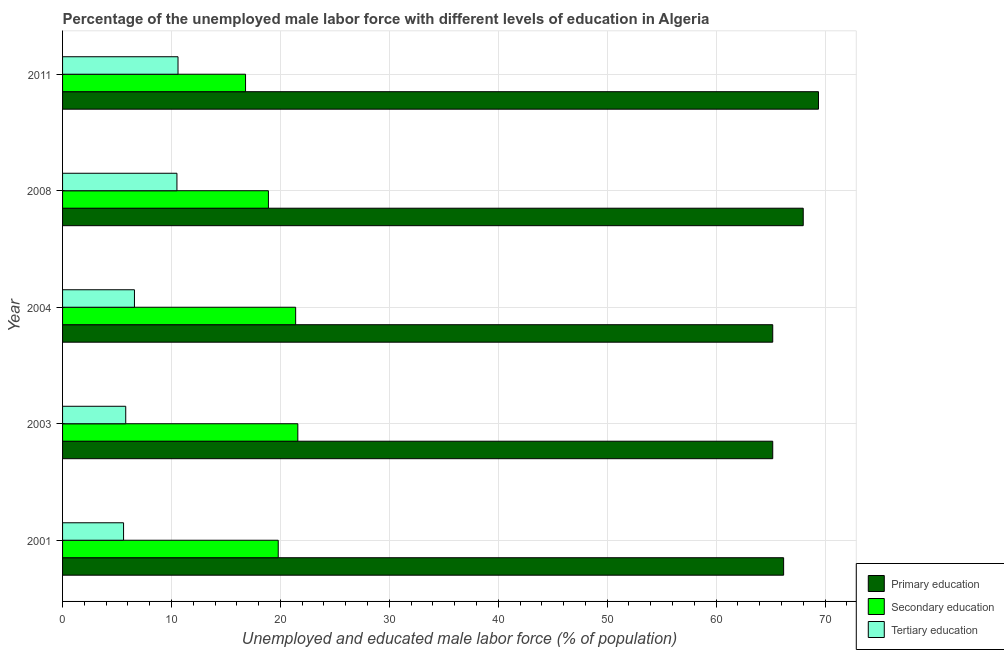How many groups of bars are there?
Offer a terse response. 5. What is the percentage of male labor force who received tertiary education in 2008?
Your answer should be very brief. 10.5. Across all years, what is the maximum percentage of male labor force who received primary education?
Keep it short and to the point. 69.4. Across all years, what is the minimum percentage of male labor force who received secondary education?
Ensure brevity in your answer.  16.8. What is the total percentage of male labor force who received tertiary education in the graph?
Provide a short and direct response. 39.1. What is the difference between the percentage of male labor force who received secondary education in 2001 and that in 2011?
Your answer should be compact. 3. What is the difference between the percentage of male labor force who received primary education in 2001 and the percentage of male labor force who received tertiary education in 2008?
Make the answer very short. 55.7. What is the average percentage of male labor force who received tertiary education per year?
Keep it short and to the point. 7.82. In the year 2008, what is the difference between the percentage of male labor force who received primary education and percentage of male labor force who received secondary education?
Provide a succinct answer. 49.1. What is the ratio of the percentage of male labor force who received secondary education in 2004 to that in 2008?
Your answer should be compact. 1.13. Is the percentage of male labor force who received secondary education in 2004 less than that in 2008?
Make the answer very short. No. Is the difference between the percentage of male labor force who received secondary education in 2003 and 2004 greater than the difference between the percentage of male labor force who received primary education in 2003 and 2004?
Your answer should be compact. Yes. What is the difference between the highest and the second highest percentage of male labor force who received primary education?
Keep it short and to the point. 1.4. What is the difference between the highest and the lowest percentage of male labor force who received primary education?
Provide a short and direct response. 4.2. Is the sum of the percentage of male labor force who received secondary education in 2008 and 2011 greater than the maximum percentage of male labor force who received tertiary education across all years?
Offer a very short reply. Yes. What does the 3rd bar from the top in 2008 represents?
Your answer should be compact. Primary education. What does the 2nd bar from the bottom in 2008 represents?
Provide a succinct answer. Secondary education. How many bars are there?
Your answer should be compact. 15. Are all the bars in the graph horizontal?
Your answer should be compact. Yes. What is the difference between two consecutive major ticks on the X-axis?
Offer a terse response. 10. Are the values on the major ticks of X-axis written in scientific E-notation?
Your answer should be compact. No. Does the graph contain any zero values?
Offer a terse response. No. Where does the legend appear in the graph?
Your response must be concise. Bottom right. What is the title of the graph?
Offer a very short reply. Percentage of the unemployed male labor force with different levels of education in Algeria. What is the label or title of the X-axis?
Give a very brief answer. Unemployed and educated male labor force (% of population). What is the Unemployed and educated male labor force (% of population) in Primary education in 2001?
Your response must be concise. 66.2. What is the Unemployed and educated male labor force (% of population) in Secondary education in 2001?
Keep it short and to the point. 19.8. What is the Unemployed and educated male labor force (% of population) of Tertiary education in 2001?
Ensure brevity in your answer.  5.6. What is the Unemployed and educated male labor force (% of population) in Primary education in 2003?
Make the answer very short. 65.2. What is the Unemployed and educated male labor force (% of population) in Secondary education in 2003?
Your answer should be very brief. 21.6. What is the Unemployed and educated male labor force (% of population) in Tertiary education in 2003?
Ensure brevity in your answer.  5.8. What is the Unemployed and educated male labor force (% of population) of Primary education in 2004?
Make the answer very short. 65.2. What is the Unemployed and educated male labor force (% of population) in Secondary education in 2004?
Offer a terse response. 21.4. What is the Unemployed and educated male labor force (% of population) in Tertiary education in 2004?
Give a very brief answer. 6.6. What is the Unemployed and educated male labor force (% of population) of Primary education in 2008?
Your response must be concise. 68. What is the Unemployed and educated male labor force (% of population) of Secondary education in 2008?
Your answer should be very brief. 18.9. What is the Unemployed and educated male labor force (% of population) of Primary education in 2011?
Give a very brief answer. 69.4. What is the Unemployed and educated male labor force (% of population) of Secondary education in 2011?
Make the answer very short. 16.8. What is the Unemployed and educated male labor force (% of population) in Tertiary education in 2011?
Your answer should be very brief. 10.6. Across all years, what is the maximum Unemployed and educated male labor force (% of population) in Primary education?
Your answer should be very brief. 69.4. Across all years, what is the maximum Unemployed and educated male labor force (% of population) in Secondary education?
Keep it short and to the point. 21.6. Across all years, what is the maximum Unemployed and educated male labor force (% of population) of Tertiary education?
Offer a very short reply. 10.6. Across all years, what is the minimum Unemployed and educated male labor force (% of population) in Primary education?
Give a very brief answer. 65.2. Across all years, what is the minimum Unemployed and educated male labor force (% of population) of Secondary education?
Offer a terse response. 16.8. Across all years, what is the minimum Unemployed and educated male labor force (% of population) in Tertiary education?
Ensure brevity in your answer.  5.6. What is the total Unemployed and educated male labor force (% of population) in Primary education in the graph?
Provide a succinct answer. 334. What is the total Unemployed and educated male labor force (% of population) in Secondary education in the graph?
Offer a very short reply. 98.5. What is the total Unemployed and educated male labor force (% of population) of Tertiary education in the graph?
Ensure brevity in your answer.  39.1. What is the difference between the Unemployed and educated male labor force (% of population) in Primary education in 2001 and that in 2003?
Provide a succinct answer. 1. What is the difference between the Unemployed and educated male labor force (% of population) of Secondary education in 2001 and that in 2003?
Your response must be concise. -1.8. What is the difference between the Unemployed and educated male labor force (% of population) of Primary education in 2001 and that in 2004?
Your answer should be compact. 1. What is the difference between the Unemployed and educated male labor force (% of population) in Secondary education in 2001 and that in 2004?
Provide a short and direct response. -1.6. What is the difference between the Unemployed and educated male labor force (% of population) of Tertiary education in 2001 and that in 2004?
Your answer should be very brief. -1. What is the difference between the Unemployed and educated male labor force (% of population) of Primary education in 2001 and that in 2008?
Keep it short and to the point. -1.8. What is the difference between the Unemployed and educated male labor force (% of population) of Tertiary education in 2001 and that in 2008?
Offer a terse response. -4.9. What is the difference between the Unemployed and educated male labor force (% of population) in Tertiary education in 2001 and that in 2011?
Provide a short and direct response. -5. What is the difference between the Unemployed and educated male labor force (% of population) in Primary education in 2003 and that in 2004?
Your answer should be compact. 0. What is the difference between the Unemployed and educated male labor force (% of population) of Tertiary education in 2003 and that in 2004?
Provide a short and direct response. -0.8. What is the difference between the Unemployed and educated male labor force (% of population) in Primary education in 2003 and that in 2011?
Your answer should be compact. -4.2. What is the difference between the Unemployed and educated male labor force (% of population) in Secondary education in 2003 and that in 2011?
Ensure brevity in your answer.  4.8. What is the difference between the Unemployed and educated male labor force (% of population) in Tertiary education in 2003 and that in 2011?
Provide a succinct answer. -4.8. What is the difference between the Unemployed and educated male labor force (% of population) of Tertiary education in 2004 and that in 2008?
Make the answer very short. -3.9. What is the difference between the Unemployed and educated male labor force (% of population) in Tertiary education in 2004 and that in 2011?
Keep it short and to the point. -4. What is the difference between the Unemployed and educated male labor force (% of population) of Primary education in 2001 and the Unemployed and educated male labor force (% of population) of Secondary education in 2003?
Ensure brevity in your answer.  44.6. What is the difference between the Unemployed and educated male labor force (% of population) in Primary education in 2001 and the Unemployed and educated male labor force (% of population) in Tertiary education in 2003?
Keep it short and to the point. 60.4. What is the difference between the Unemployed and educated male labor force (% of population) of Secondary education in 2001 and the Unemployed and educated male labor force (% of population) of Tertiary education in 2003?
Give a very brief answer. 14. What is the difference between the Unemployed and educated male labor force (% of population) in Primary education in 2001 and the Unemployed and educated male labor force (% of population) in Secondary education in 2004?
Give a very brief answer. 44.8. What is the difference between the Unemployed and educated male labor force (% of population) of Primary education in 2001 and the Unemployed and educated male labor force (% of population) of Tertiary education in 2004?
Your answer should be very brief. 59.6. What is the difference between the Unemployed and educated male labor force (% of population) in Primary education in 2001 and the Unemployed and educated male labor force (% of population) in Secondary education in 2008?
Your response must be concise. 47.3. What is the difference between the Unemployed and educated male labor force (% of population) of Primary education in 2001 and the Unemployed and educated male labor force (% of population) of Tertiary education in 2008?
Give a very brief answer. 55.7. What is the difference between the Unemployed and educated male labor force (% of population) in Primary education in 2001 and the Unemployed and educated male labor force (% of population) in Secondary education in 2011?
Provide a short and direct response. 49.4. What is the difference between the Unemployed and educated male labor force (% of population) in Primary education in 2001 and the Unemployed and educated male labor force (% of population) in Tertiary education in 2011?
Provide a short and direct response. 55.6. What is the difference between the Unemployed and educated male labor force (% of population) of Primary education in 2003 and the Unemployed and educated male labor force (% of population) of Secondary education in 2004?
Provide a succinct answer. 43.8. What is the difference between the Unemployed and educated male labor force (% of population) of Primary education in 2003 and the Unemployed and educated male labor force (% of population) of Tertiary education in 2004?
Provide a short and direct response. 58.6. What is the difference between the Unemployed and educated male labor force (% of population) of Primary education in 2003 and the Unemployed and educated male labor force (% of population) of Secondary education in 2008?
Your answer should be compact. 46.3. What is the difference between the Unemployed and educated male labor force (% of population) in Primary education in 2003 and the Unemployed and educated male labor force (% of population) in Tertiary education in 2008?
Provide a short and direct response. 54.7. What is the difference between the Unemployed and educated male labor force (% of population) in Primary education in 2003 and the Unemployed and educated male labor force (% of population) in Secondary education in 2011?
Ensure brevity in your answer.  48.4. What is the difference between the Unemployed and educated male labor force (% of population) of Primary education in 2003 and the Unemployed and educated male labor force (% of population) of Tertiary education in 2011?
Offer a terse response. 54.6. What is the difference between the Unemployed and educated male labor force (% of population) of Secondary education in 2003 and the Unemployed and educated male labor force (% of population) of Tertiary education in 2011?
Keep it short and to the point. 11. What is the difference between the Unemployed and educated male labor force (% of population) in Primary education in 2004 and the Unemployed and educated male labor force (% of population) in Secondary education in 2008?
Your response must be concise. 46.3. What is the difference between the Unemployed and educated male labor force (% of population) in Primary education in 2004 and the Unemployed and educated male labor force (% of population) in Tertiary education in 2008?
Provide a short and direct response. 54.7. What is the difference between the Unemployed and educated male labor force (% of population) in Primary education in 2004 and the Unemployed and educated male labor force (% of population) in Secondary education in 2011?
Provide a short and direct response. 48.4. What is the difference between the Unemployed and educated male labor force (% of population) of Primary education in 2004 and the Unemployed and educated male labor force (% of population) of Tertiary education in 2011?
Your answer should be very brief. 54.6. What is the difference between the Unemployed and educated male labor force (% of population) in Primary education in 2008 and the Unemployed and educated male labor force (% of population) in Secondary education in 2011?
Give a very brief answer. 51.2. What is the difference between the Unemployed and educated male labor force (% of population) of Primary education in 2008 and the Unemployed and educated male labor force (% of population) of Tertiary education in 2011?
Give a very brief answer. 57.4. What is the average Unemployed and educated male labor force (% of population) of Primary education per year?
Your answer should be compact. 66.8. What is the average Unemployed and educated male labor force (% of population) of Secondary education per year?
Keep it short and to the point. 19.7. What is the average Unemployed and educated male labor force (% of population) of Tertiary education per year?
Make the answer very short. 7.82. In the year 2001, what is the difference between the Unemployed and educated male labor force (% of population) in Primary education and Unemployed and educated male labor force (% of population) in Secondary education?
Keep it short and to the point. 46.4. In the year 2001, what is the difference between the Unemployed and educated male labor force (% of population) of Primary education and Unemployed and educated male labor force (% of population) of Tertiary education?
Offer a very short reply. 60.6. In the year 2001, what is the difference between the Unemployed and educated male labor force (% of population) of Secondary education and Unemployed and educated male labor force (% of population) of Tertiary education?
Ensure brevity in your answer.  14.2. In the year 2003, what is the difference between the Unemployed and educated male labor force (% of population) of Primary education and Unemployed and educated male labor force (% of population) of Secondary education?
Make the answer very short. 43.6. In the year 2003, what is the difference between the Unemployed and educated male labor force (% of population) of Primary education and Unemployed and educated male labor force (% of population) of Tertiary education?
Your answer should be compact. 59.4. In the year 2004, what is the difference between the Unemployed and educated male labor force (% of population) of Primary education and Unemployed and educated male labor force (% of population) of Secondary education?
Offer a terse response. 43.8. In the year 2004, what is the difference between the Unemployed and educated male labor force (% of population) in Primary education and Unemployed and educated male labor force (% of population) in Tertiary education?
Your response must be concise. 58.6. In the year 2004, what is the difference between the Unemployed and educated male labor force (% of population) of Secondary education and Unemployed and educated male labor force (% of population) of Tertiary education?
Offer a very short reply. 14.8. In the year 2008, what is the difference between the Unemployed and educated male labor force (% of population) of Primary education and Unemployed and educated male labor force (% of population) of Secondary education?
Keep it short and to the point. 49.1. In the year 2008, what is the difference between the Unemployed and educated male labor force (% of population) of Primary education and Unemployed and educated male labor force (% of population) of Tertiary education?
Your response must be concise. 57.5. In the year 2011, what is the difference between the Unemployed and educated male labor force (% of population) in Primary education and Unemployed and educated male labor force (% of population) in Secondary education?
Offer a very short reply. 52.6. In the year 2011, what is the difference between the Unemployed and educated male labor force (% of population) of Primary education and Unemployed and educated male labor force (% of population) of Tertiary education?
Ensure brevity in your answer.  58.8. In the year 2011, what is the difference between the Unemployed and educated male labor force (% of population) in Secondary education and Unemployed and educated male labor force (% of population) in Tertiary education?
Offer a terse response. 6.2. What is the ratio of the Unemployed and educated male labor force (% of population) of Primary education in 2001 to that in 2003?
Your answer should be compact. 1.02. What is the ratio of the Unemployed and educated male labor force (% of population) of Tertiary education in 2001 to that in 2003?
Your answer should be compact. 0.97. What is the ratio of the Unemployed and educated male labor force (% of population) in Primary education in 2001 to that in 2004?
Your answer should be compact. 1.02. What is the ratio of the Unemployed and educated male labor force (% of population) of Secondary education in 2001 to that in 2004?
Make the answer very short. 0.93. What is the ratio of the Unemployed and educated male labor force (% of population) in Tertiary education in 2001 to that in 2004?
Your answer should be very brief. 0.85. What is the ratio of the Unemployed and educated male labor force (% of population) of Primary education in 2001 to that in 2008?
Your answer should be very brief. 0.97. What is the ratio of the Unemployed and educated male labor force (% of population) in Secondary education in 2001 to that in 2008?
Your answer should be very brief. 1.05. What is the ratio of the Unemployed and educated male labor force (% of population) of Tertiary education in 2001 to that in 2008?
Your answer should be compact. 0.53. What is the ratio of the Unemployed and educated male labor force (% of population) in Primary education in 2001 to that in 2011?
Offer a terse response. 0.95. What is the ratio of the Unemployed and educated male labor force (% of population) of Secondary education in 2001 to that in 2011?
Your response must be concise. 1.18. What is the ratio of the Unemployed and educated male labor force (% of population) in Tertiary education in 2001 to that in 2011?
Your response must be concise. 0.53. What is the ratio of the Unemployed and educated male labor force (% of population) of Primary education in 2003 to that in 2004?
Keep it short and to the point. 1. What is the ratio of the Unemployed and educated male labor force (% of population) in Secondary education in 2003 to that in 2004?
Your answer should be very brief. 1.01. What is the ratio of the Unemployed and educated male labor force (% of population) of Tertiary education in 2003 to that in 2004?
Give a very brief answer. 0.88. What is the ratio of the Unemployed and educated male labor force (% of population) of Primary education in 2003 to that in 2008?
Provide a short and direct response. 0.96. What is the ratio of the Unemployed and educated male labor force (% of population) in Secondary education in 2003 to that in 2008?
Ensure brevity in your answer.  1.14. What is the ratio of the Unemployed and educated male labor force (% of population) of Tertiary education in 2003 to that in 2008?
Ensure brevity in your answer.  0.55. What is the ratio of the Unemployed and educated male labor force (% of population) in Primary education in 2003 to that in 2011?
Keep it short and to the point. 0.94. What is the ratio of the Unemployed and educated male labor force (% of population) in Secondary education in 2003 to that in 2011?
Ensure brevity in your answer.  1.29. What is the ratio of the Unemployed and educated male labor force (% of population) of Tertiary education in 2003 to that in 2011?
Your response must be concise. 0.55. What is the ratio of the Unemployed and educated male labor force (% of population) in Primary education in 2004 to that in 2008?
Offer a very short reply. 0.96. What is the ratio of the Unemployed and educated male labor force (% of population) of Secondary education in 2004 to that in 2008?
Your response must be concise. 1.13. What is the ratio of the Unemployed and educated male labor force (% of population) of Tertiary education in 2004 to that in 2008?
Give a very brief answer. 0.63. What is the ratio of the Unemployed and educated male labor force (% of population) in Primary education in 2004 to that in 2011?
Your answer should be very brief. 0.94. What is the ratio of the Unemployed and educated male labor force (% of population) in Secondary education in 2004 to that in 2011?
Offer a very short reply. 1.27. What is the ratio of the Unemployed and educated male labor force (% of population) in Tertiary education in 2004 to that in 2011?
Offer a very short reply. 0.62. What is the ratio of the Unemployed and educated male labor force (% of population) in Primary education in 2008 to that in 2011?
Ensure brevity in your answer.  0.98. What is the ratio of the Unemployed and educated male labor force (% of population) in Tertiary education in 2008 to that in 2011?
Keep it short and to the point. 0.99. What is the difference between the highest and the second highest Unemployed and educated male labor force (% of population) in Primary education?
Provide a short and direct response. 1.4. What is the difference between the highest and the second highest Unemployed and educated male labor force (% of population) in Secondary education?
Your answer should be very brief. 0.2. What is the difference between the highest and the second highest Unemployed and educated male labor force (% of population) of Tertiary education?
Ensure brevity in your answer.  0.1. What is the difference between the highest and the lowest Unemployed and educated male labor force (% of population) of Primary education?
Your answer should be compact. 4.2. What is the difference between the highest and the lowest Unemployed and educated male labor force (% of population) in Tertiary education?
Your response must be concise. 5. 